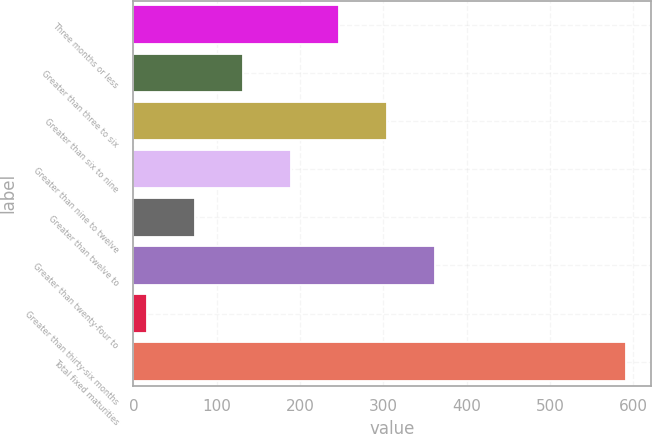Convert chart to OTSL. <chart><loc_0><loc_0><loc_500><loc_500><bar_chart><fcel>Three months or less<fcel>Greater than three to six<fcel>Greater than six to nine<fcel>Greater than nine to twelve<fcel>Greater than twelve to<fcel>Greater than twenty-four to<fcel>Greater than thirty-six months<fcel>Total fixed maturities<nl><fcel>246.7<fcel>131.6<fcel>304.25<fcel>189.15<fcel>74.05<fcel>361.8<fcel>16.5<fcel>592<nl></chart> 